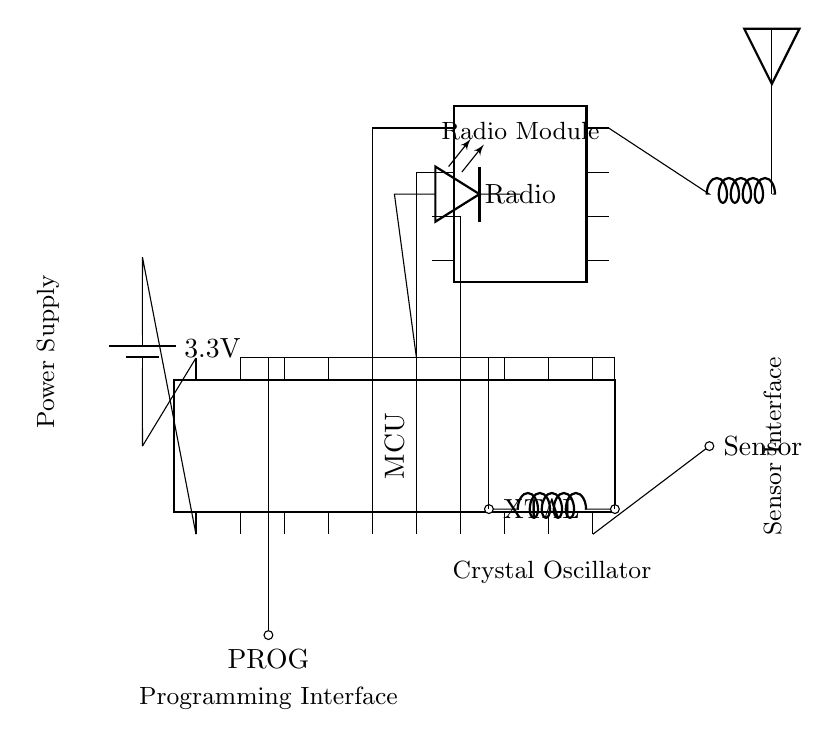What is the power supply voltage for this circuit? The schematic shows a battery connected to the circuit that specifies a voltage of 3.3V, indicated on the connection to the power supply.
Answer: 3.3V What is the function of the component labeled as "XTAL"? In the circuit, the label "XTAL" indicates it is a Crystal Oscillator, which is used to provide a stable clock signal to the microcontroller for timing purposes.
Answer: Crystal Oscillator How many pins does the microcontroller have? The microcontroller (MCU) in the diagram is specified to have 20 pins, as indicated by the labeling on the dipchip symbol.
Answer: 20 pins Which component connects to pin 10 of the microcontroller? Looking at the connections, the component connected to pin 10 of the microcontroller is labeled as "Sensor," making it clear that this pin interfaces with the sensor.
Answer: Sensor What is the purpose of the radio module in the circuit? The radio module's purpose is to facilitate data transmission wirelessly. It connects to the microcontroller via three pins, indicating a communication pathway that is essential for remote patient monitoring.
Answer: Data transmission Why is there an LED connected to the microcontroller? The LED connected to the microcontroller (noted on pin 15) serves as an indicator light, which can signal various statuses or activities of the circuit, such as power on or data transmission.
Answer: Indicator light What does the connection labeled "PROG" signify in this circuit? The "PROG" label refers to a programming interface, which allows the microcontroller to be programmed or reprogrammed. It is connected to pin 17, enabling configuration during development or updates.
Answer: Programming interface 